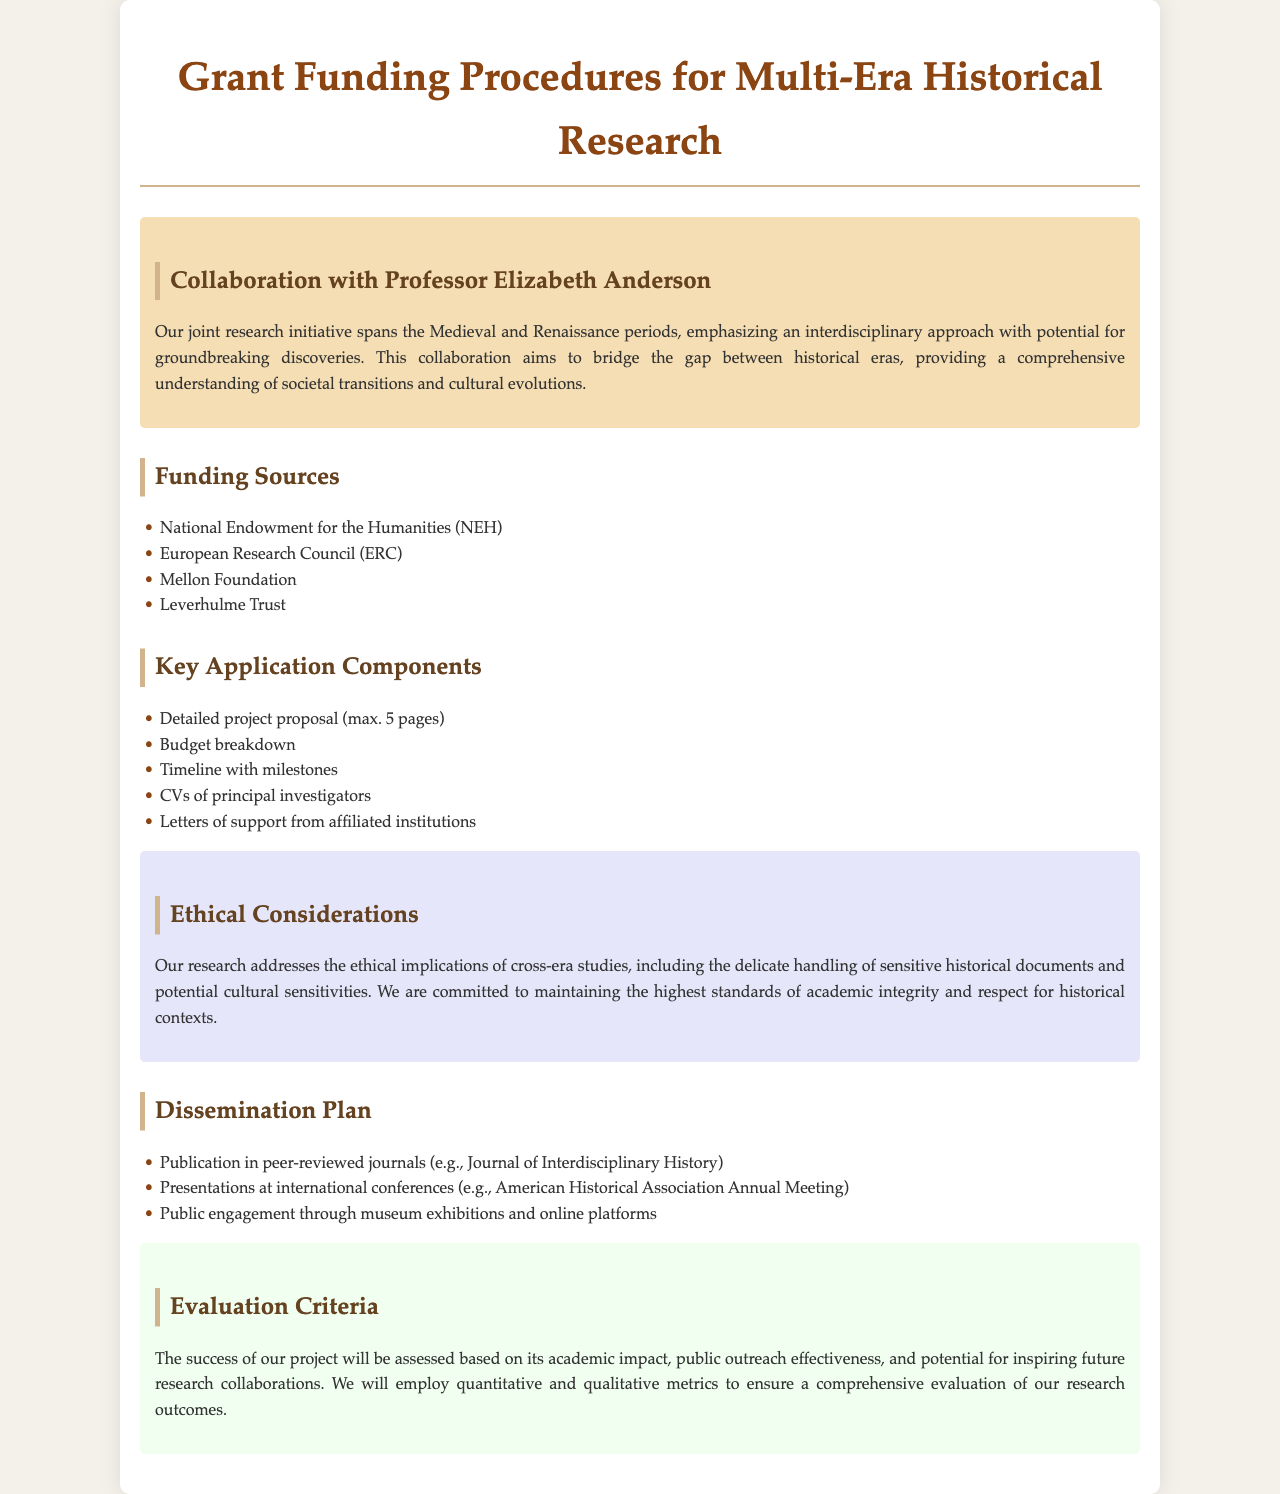What is the title of the document? The title of the document is mentioned at the top and reflects its purpose.
Answer: Grant Funding Procedures for Multi-Era Historical Research Who is collaborating on the research initiative? The document identifies the collaborator involved in the joint research initiative.
Answer: Professor Elizabeth Anderson What is the maximum length of the project proposal? The document specifies the length limit for the detailed project proposal required for the application.
Answer: 5 pages Name one funding source listed in the document. There are several funding sources provided; one example is asked here.
Answer: National Endowment for the Humanities (NEH) What is one ethical consideration mentioned in the document? Aspects of ethical handling are emphasized, particularly regarding historical research practices.
Answer: Sensitive historical documents What type of publications are suggested for dissemination? The document indicates what kinds of publications should feature the research findings post-project.
Answer: Peer-reviewed journals What is the focus of the evaluation criteria? The document outlines what elements will be considered to assess the success of the research project.
Answer: Academic impact What is one of the components required for the application? The document lists components that must be included in the funding application, one of which is asked here.
Answer: Budget breakdown 